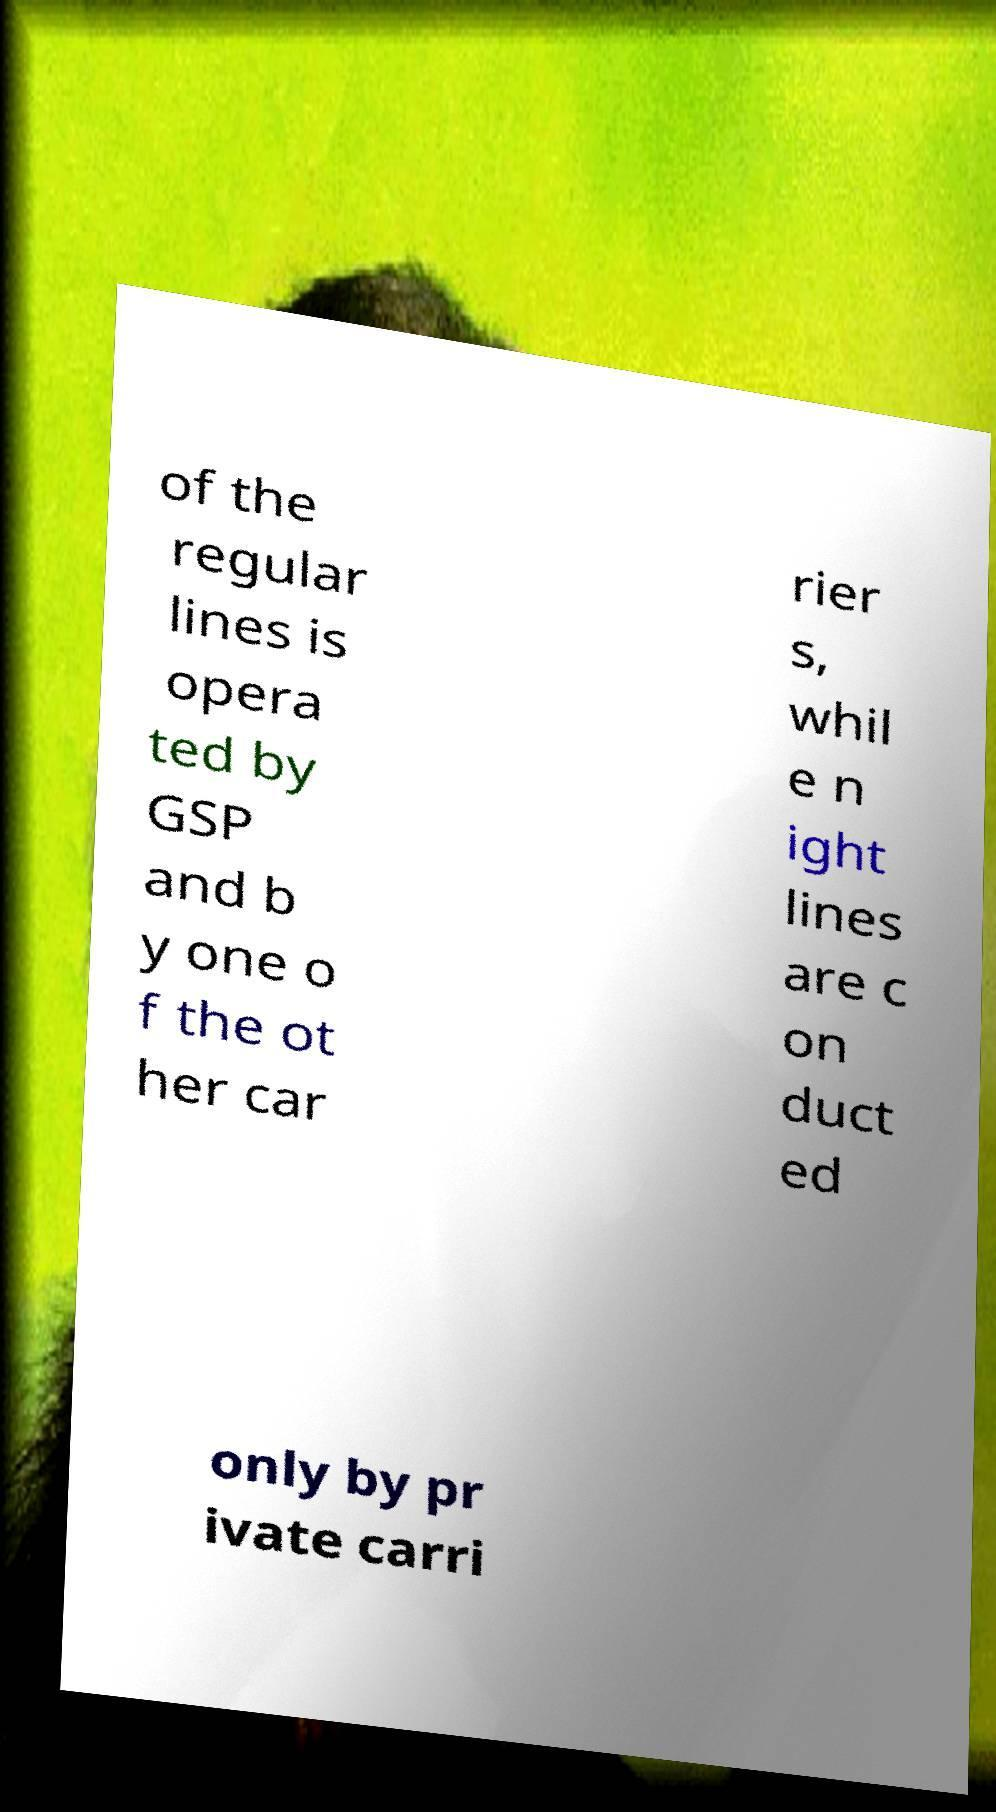Can you read and provide the text displayed in the image?This photo seems to have some interesting text. Can you extract and type it out for me? of the regular lines is opera ted by GSP and b y one o f the ot her car rier s, whil e n ight lines are c on duct ed only by pr ivate carri 